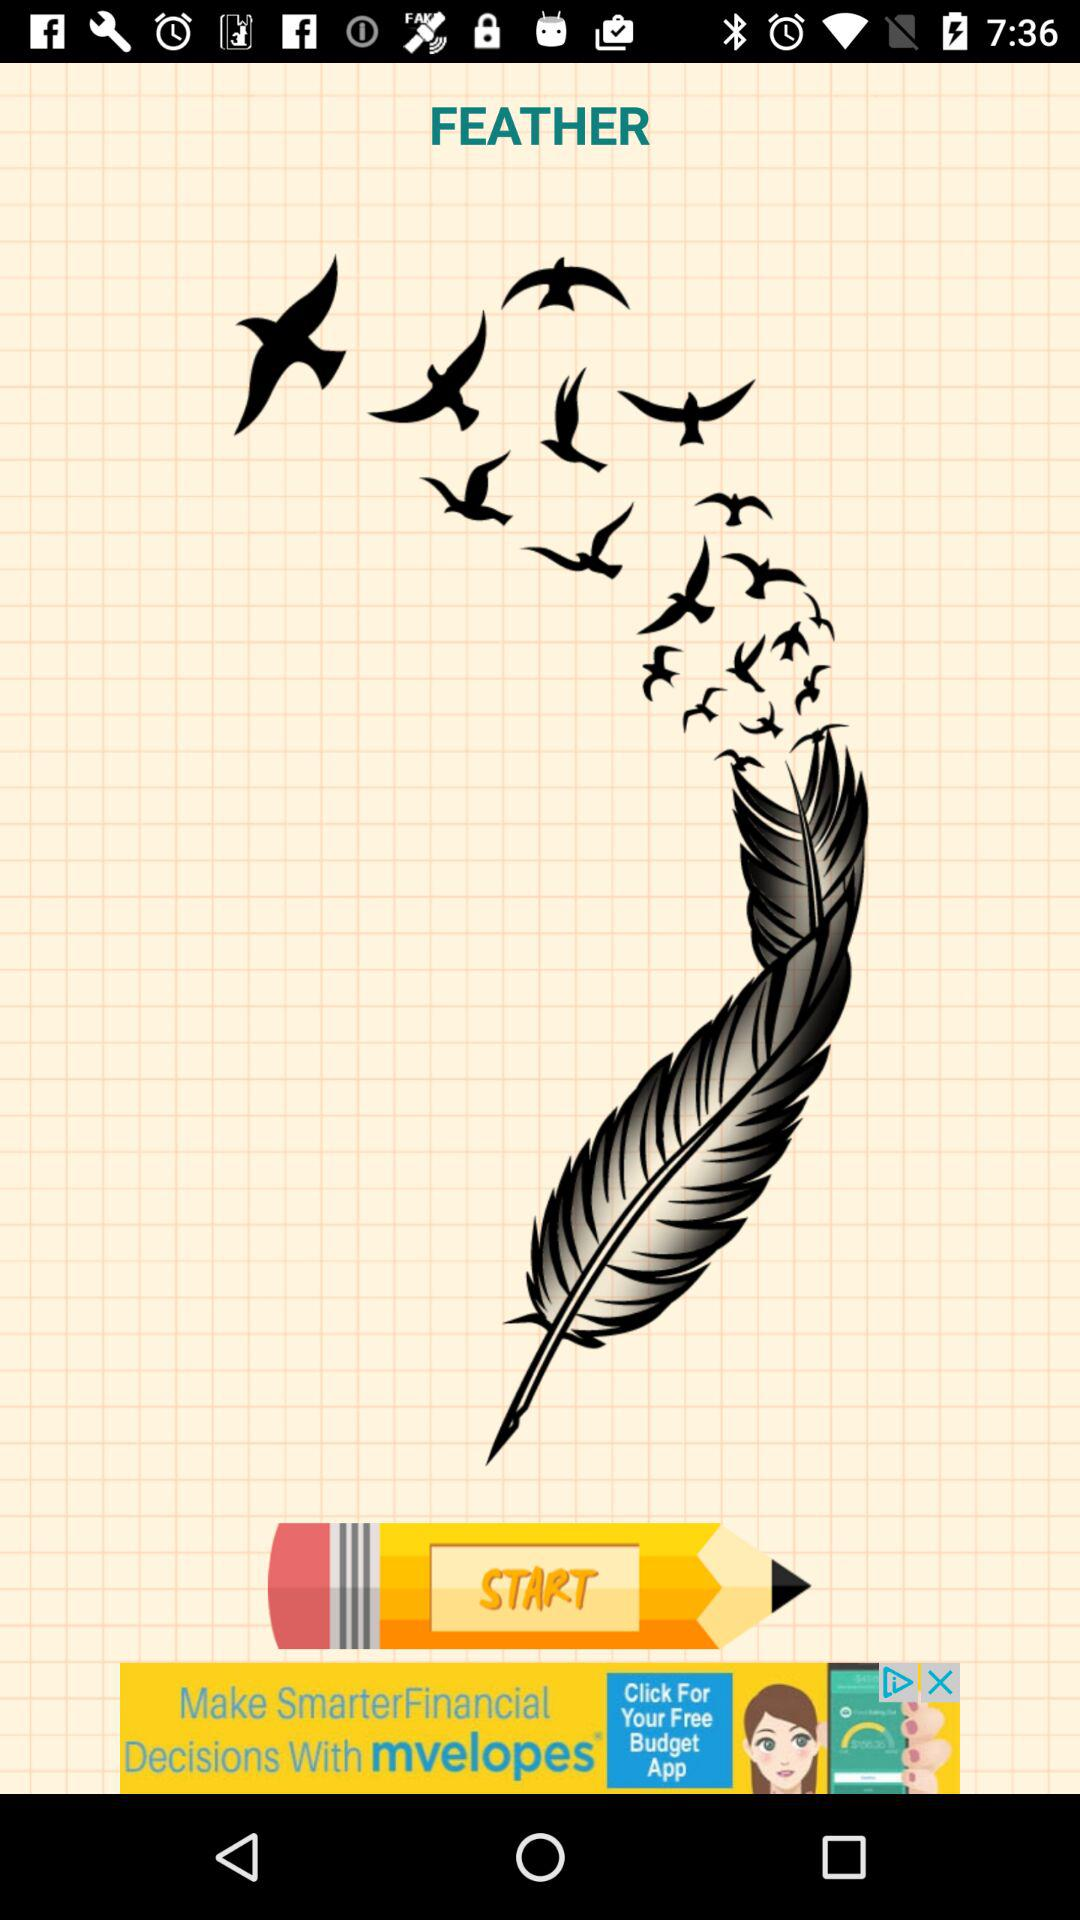What is the name of the application?
When the provided information is insufficient, respond with <no answer>. <no answer> 